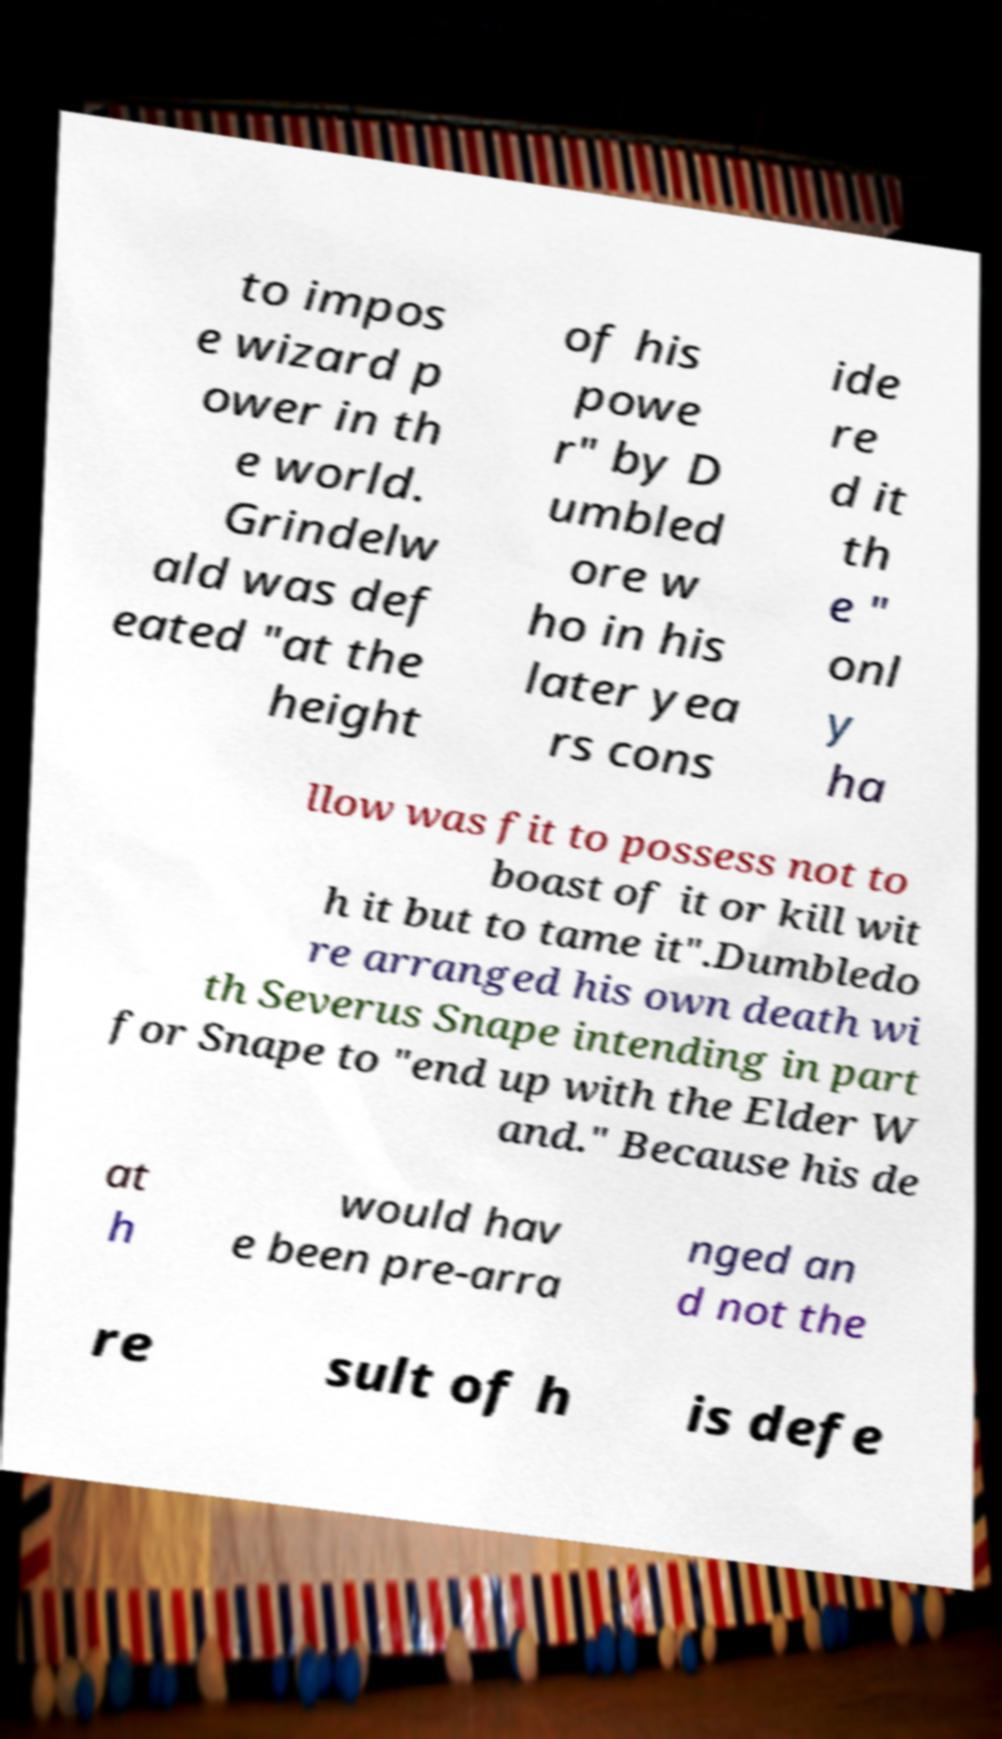Please read and relay the text visible in this image. What does it say? to impos e wizard p ower in th e world. Grindelw ald was def eated "at the height of his powe r" by D umbled ore w ho in his later yea rs cons ide re d it th e " onl y ha llow was fit to possess not to boast of it or kill wit h it but to tame it".Dumbledo re arranged his own death wi th Severus Snape intending in part for Snape to "end up with the Elder W and." Because his de at h would hav e been pre-arra nged an d not the re sult of h is defe 